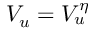Convert formula to latex. <formula><loc_0><loc_0><loc_500><loc_500>V _ { u } = V _ { u } ^ { \eta }</formula> 